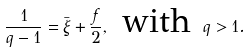Convert formula to latex. <formula><loc_0><loc_0><loc_500><loc_500>\frac { 1 } { q - 1 } = \bar { \xi } + \frac { f } { 2 } , \text { with  } q > 1 .</formula> 